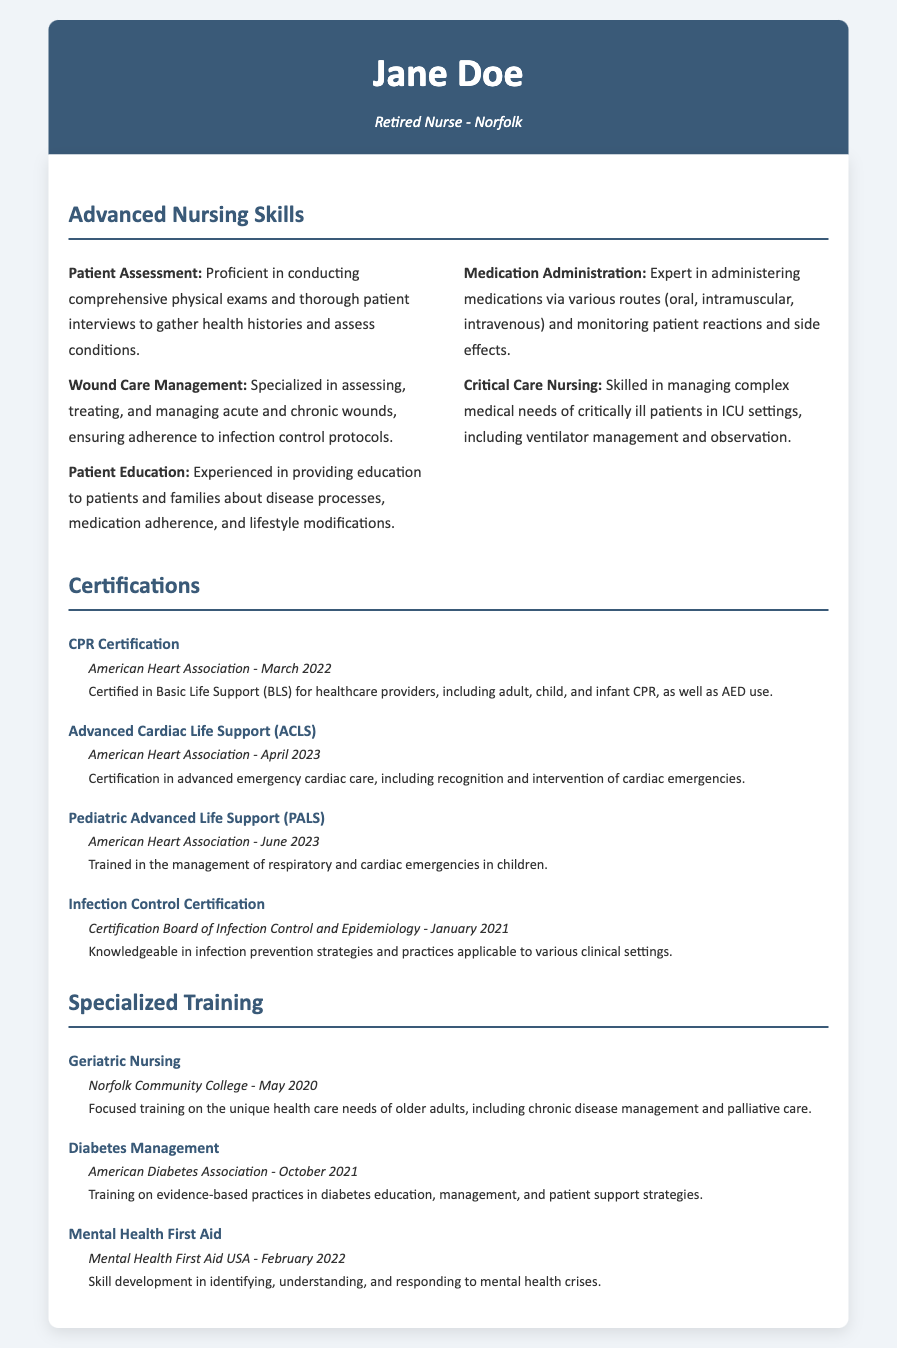what is the name of the retired nurse? The document mentions the name of the retired nurse in the header section, which is listed as Jane Doe.
Answer: Jane Doe when did Jane Doe receive her CPR certification? The CPR certification date is included in the certification section, indicating when it was awarded.
Answer: March 2022 which organization issued the Advanced Cardiac Life Support certification? The issuing organization for the ACLS certification is specified in the certification details.
Answer: American Heart Association what specialized training did Jane Doe complete in May 2020? The specialized training section lists training programs along with their completion dates, specifically for geriatric nursing.
Answer: Geriatric Nursing how many advanced nursing skills are listed in the document? The number of skills is counted in the advanced nursing skills section, providing a total count of the skills mentioned.
Answer: Five what type of emergencies does the Pediatric Advanced Life Support training address? The document outlines the focus areas of the PALS training, which involve specific emergency situations.
Answer: Respiratory and cardiac emergencies what is the focus of the Diabetes Management training? The document includes details on the focus of the training program related to diabetes.
Answer: Evidence-based practices in diabetes education which certification was awarded in January 2021? The certification section lists various certifications along with their dates, indicating which was issued at that time.
Answer: Infection Control Certification how did Jane Doe enhance her skills in mental health? The training section provides information on the focus of the mental health training program completed by Jane Doe.
Answer: Mental Health First Aid 